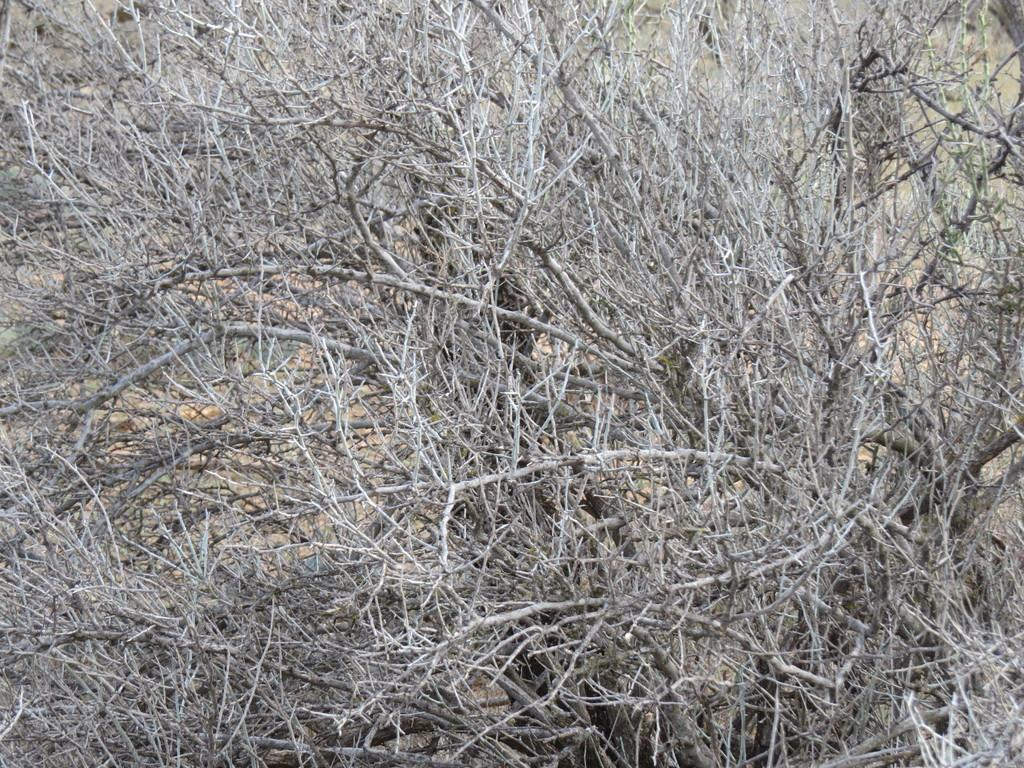What type of vegetation can be seen in the image? There are branches of trees and twigs in the image. What is the ground made of in the image? Soil is visible on the floor in the image. What type of animals can be seen in the zoo in the image? There is no zoo or animals present in the image; it features branches of trees, twigs, and soil. 